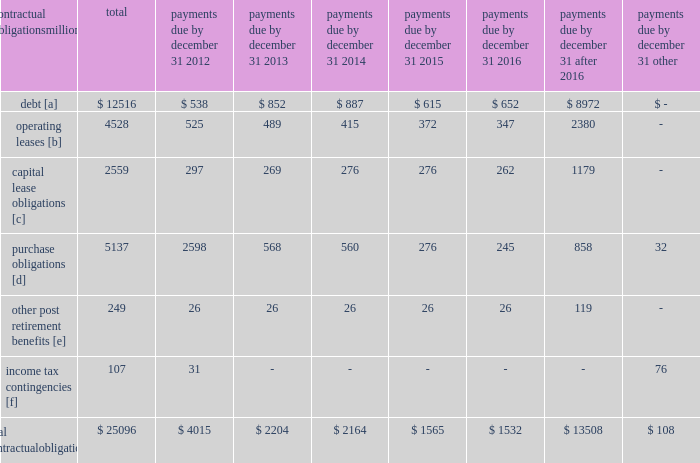The railroad collected approximately $ 18.8 billion and $ 16.3 billion of receivables during the years ended december 31 , 2011 and 2010 , respectively .
Upri used certain of these proceeds to purchase new receivables under the facility .
The costs of the receivables securitization facility include interest , which will vary based on prevailing commercial paper rates , program fees paid to banks , commercial paper issuing costs , and fees for unused commitment availability .
The costs of the receivables securitization facility are included in interest expense and were $ 4 million and $ 6 million for 2011 and 2010 , respectively .
Prior to adoption of the new accounting standard , the costs of the receivables securitization facility were included in other income and were $ 9 million for 2009 .
The investors have no recourse to the railroad 2019s other assets , except for customary warranty and indemnity claims .
Creditors of the railroad do not have recourse to the assets of upri .
In august 2011 , the receivables securitization facility was renewed for an additional 364-day period at comparable terms and conditions .
Contractual obligations and commercial commitments as described in the notes to the consolidated financial statements and as referenced in the tables below , we have contractual obligations and commercial commitments that may affect our financial condition .
Based on our assessment of the underlying provisions and circumstances of our contractual obligations and commercial commitments , including material sources of off-balance sheet and structured finance arrangements , other than the risks that we and other similarly situated companies face with respect to the condition of the capital markets ( as described in item 1a of part ii of this report ) , there is no known trend , demand , commitment , event , or uncertainty that is reasonably likely to occur that would have a material adverse effect on our consolidated results of operations , financial condition , or liquidity .
In addition , our commercial obligations , financings , and commitments are customary transactions that are similar to those of other comparable corporations , particularly within the transportation industry .
The tables identify material obligations and commitments as of december 31 , 2011 : payments due by december 31 , contractual obligations after millions total 2012 2013 2014 2015 2016 2016 other .
[a] excludes capital lease obligations of $ 1874 million and unamortized discount of $ 364 million .
Includes an interest component of $ 5120 million .
[b] includes leases for locomotives , freight cars , other equipment , and real estate .
[c] represents total obligations , including interest component of $ 685 million .
[d] purchase obligations include locomotive maintenance contracts ; purchase commitments for fuel purchases , locomotives , ties , ballast , and rail ; and agreements to purchase other goods and services .
For amounts where we cannot reasonably estimate the year of settlement , they are reflected in the other column .
[e] includes estimated other post retirement , medical , and life insurance payments and payments made under the unfunded pension plan for the next ten years .
No amounts are included for funded pension obligations as no contributions are currently required .
[f] future cash flows for income tax contingencies reflect the recorded liability for unrecognized tax benefits , including interest and penalties , as of december 31 , 2011 .
Where we can reasonably estimate the years in which these liabilities may be settled , this is shown in the table .
For amounts where we cannot reasonably estimate the year of settlement , they are reflected in the other column. .
What percentage of total material obligations and commitments as of december 31 , 2011 are operating leases? 
Computations: (4528 / 25096)
Answer: 0.18043. 